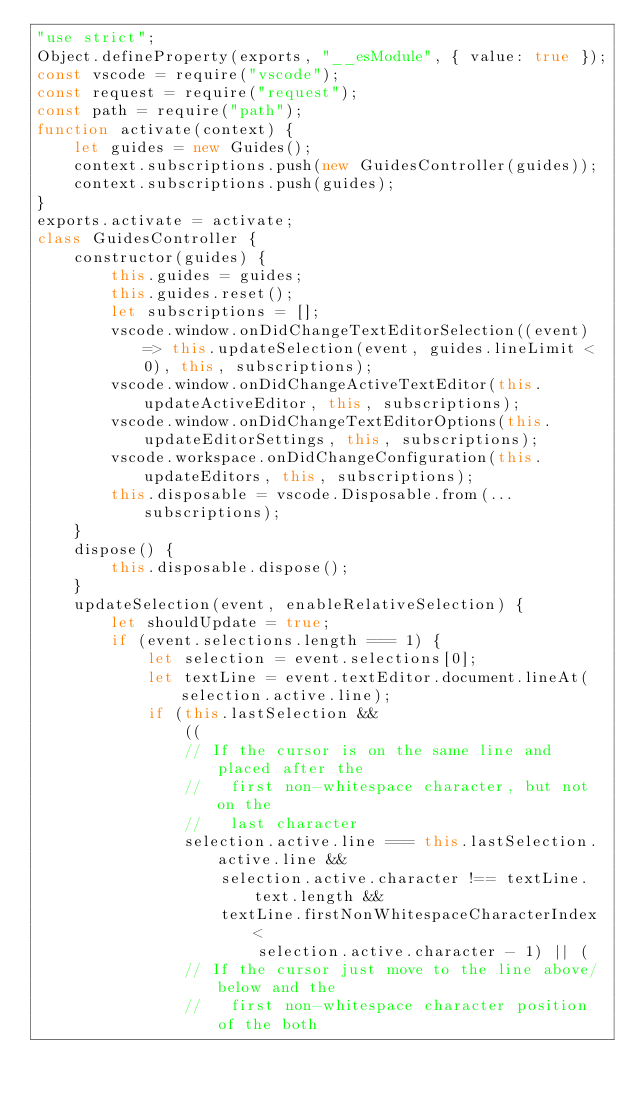Convert code to text. <code><loc_0><loc_0><loc_500><loc_500><_JavaScript_>"use strict";
Object.defineProperty(exports, "__esModule", { value: true });
const vscode = require("vscode");
const request = require("request");
const path = require("path");
function activate(context) {
    let guides = new Guides();
    context.subscriptions.push(new GuidesController(guides));
    context.subscriptions.push(guides);
}
exports.activate = activate;
class GuidesController {
    constructor(guides) {
        this.guides = guides;
        this.guides.reset();
        let subscriptions = [];
        vscode.window.onDidChangeTextEditorSelection((event) => this.updateSelection(event, guides.lineLimit < 0), this, subscriptions);
        vscode.window.onDidChangeActiveTextEditor(this.updateActiveEditor, this, subscriptions);
        vscode.window.onDidChangeTextEditorOptions(this.updateEditorSettings, this, subscriptions);
        vscode.workspace.onDidChangeConfiguration(this.updateEditors, this, subscriptions);
        this.disposable = vscode.Disposable.from(...subscriptions);
    }
    dispose() {
        this.disposable.dispose();
    }
    updateSelection(event, enableRelativeSelection) {
        let shouldUpdate = true;
        if (event.selections.length === 1) {
            let selection = event.selections[0];
            let textLine = event.textEditor.document.lineAt(selection.active.line);
            if (this.lastSelection &&
                ((
                // If the cursor is on the same line and placed after the
                //   first non-whitespace character, but not on the
                //   last character
                selection.active.line === this.lastSelection.active.line &&
                    selection.active.character !== textLine.text.length &&
                    textLine.firstNonWhitespaceCharacterIndex <
                        selection.active.character - 1) || (
                // If the cursor just move to the line above/below and the
                //   first non-whitespace character position of the both</code> 